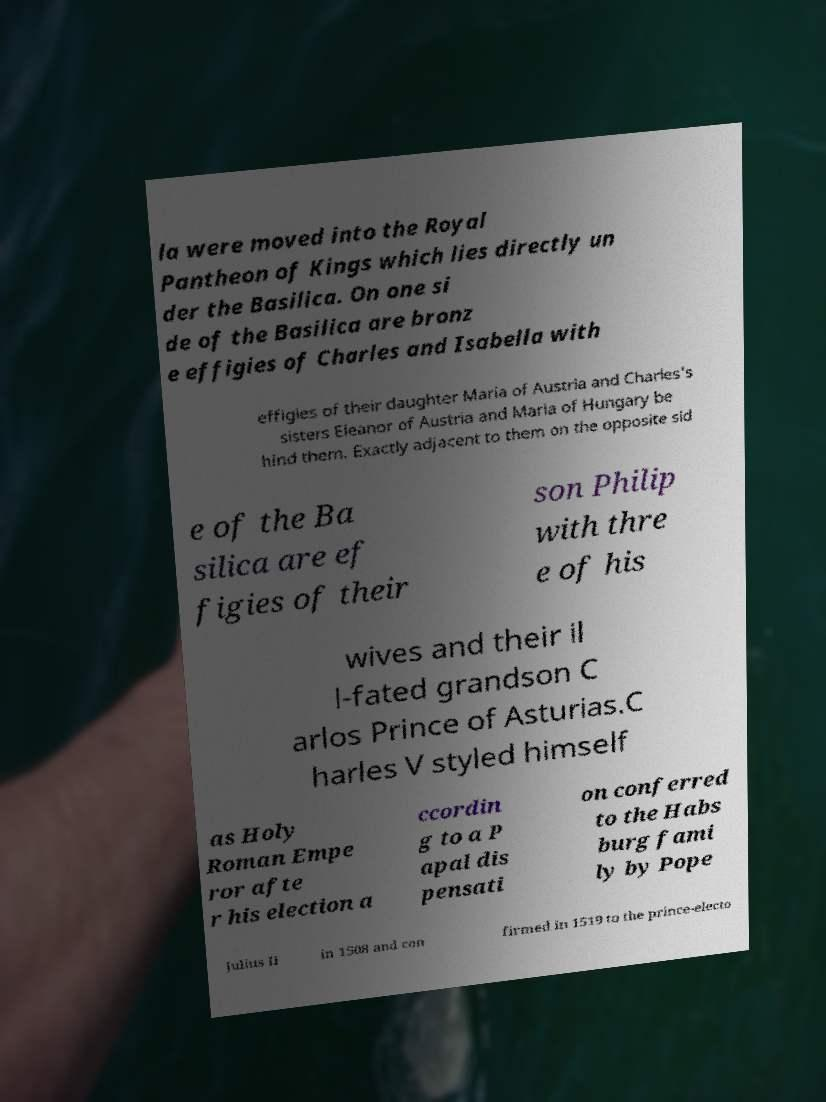Could you assist in decoding the text presented in this image and type it out clearly? la were moved into the Royal Pantheon of Kings which lies directly un der the Basilica. On one si de of the Basilica are bronz e effigies of Charles and Isabella with effigies of their daughter Maria of Austria and Charles's sisters Eleanor of Austria and Maria of Hungary be hind them. Exactly adjacent to them on the opposite sid e of the Ba silica are ef figies of their son Philip with thre e of his wives and their il l-fated grandson C arlos Prince of Asturias.C harles V styled himself as Holy Roman Empe ror afte r his election a ccordin g to a P apal dis pensati on conferred to the Habs burg fami ly by Pope Julius II in 1508 and con firmed in 1519 to the prince-electo 